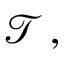Convert formula to latex. <formula><loc_0><loc_0><loc_500><loc_500>{ \mathcal { T } } \, ,</formula> 